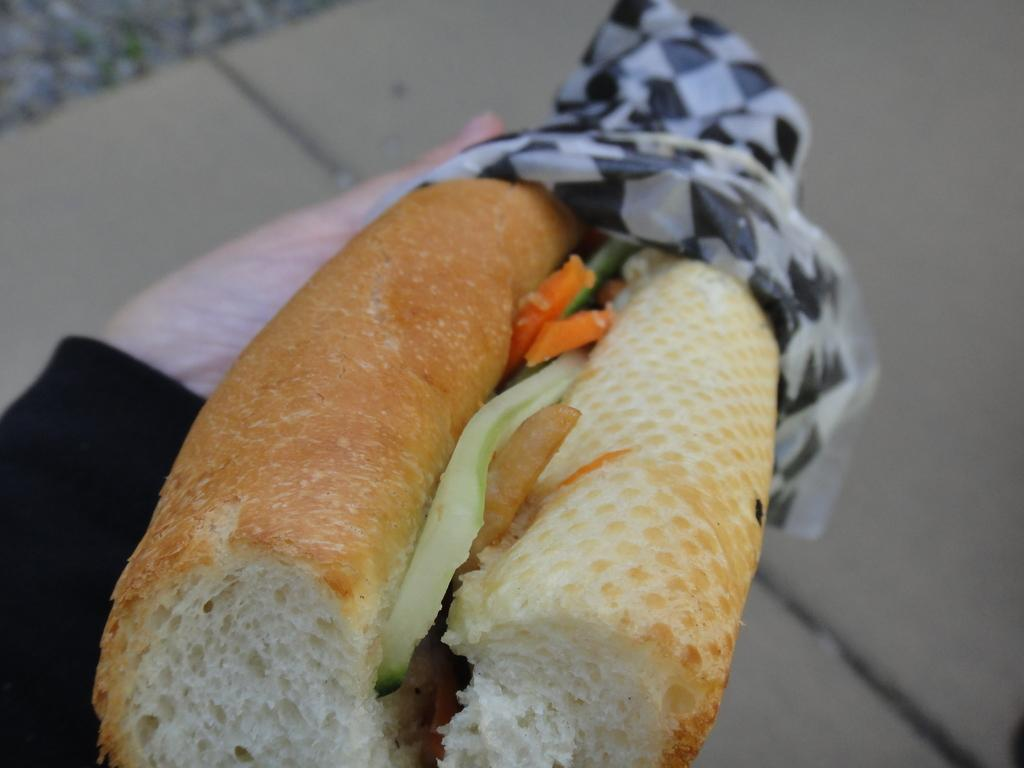What is being held by someone in the image? There is food in someone's hand in the image. Can you describe the food being held? Unfortunately, the specific type of food cannot be determined from the image. What might the person holding the food be doing? The person holding the food might be about to eat it or offer it to someone else. What type of cord is being used by the parent to express love in the image? There is no parent, love, or cord present in the image. The image only shows food being held by someone. 